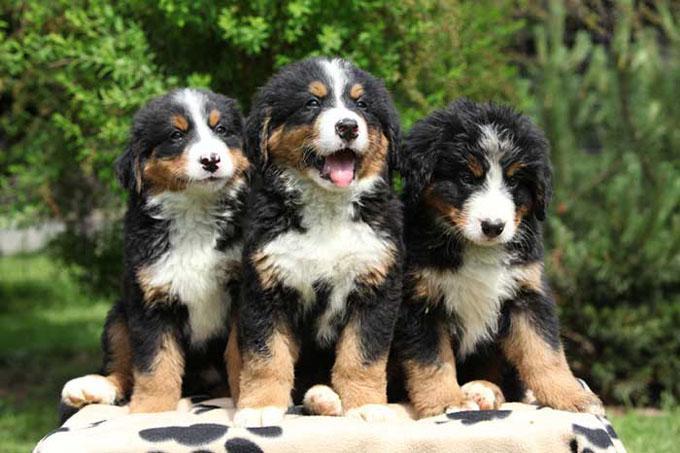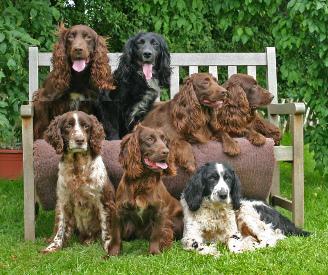The first image is the image on the left, the second image is the image on the right. For the images displayed, is the sentence "The left image contains a single standing dog, and the right image shows two dogs interacting outdoors." factually correct? Answer yes or no. No. The first image is the image on the left, the second image is the image on the right. For the images displayed, is the sentence "In one of the images there are 2 dogs playing on the grass." factually correct? Answer yes or no. No. 